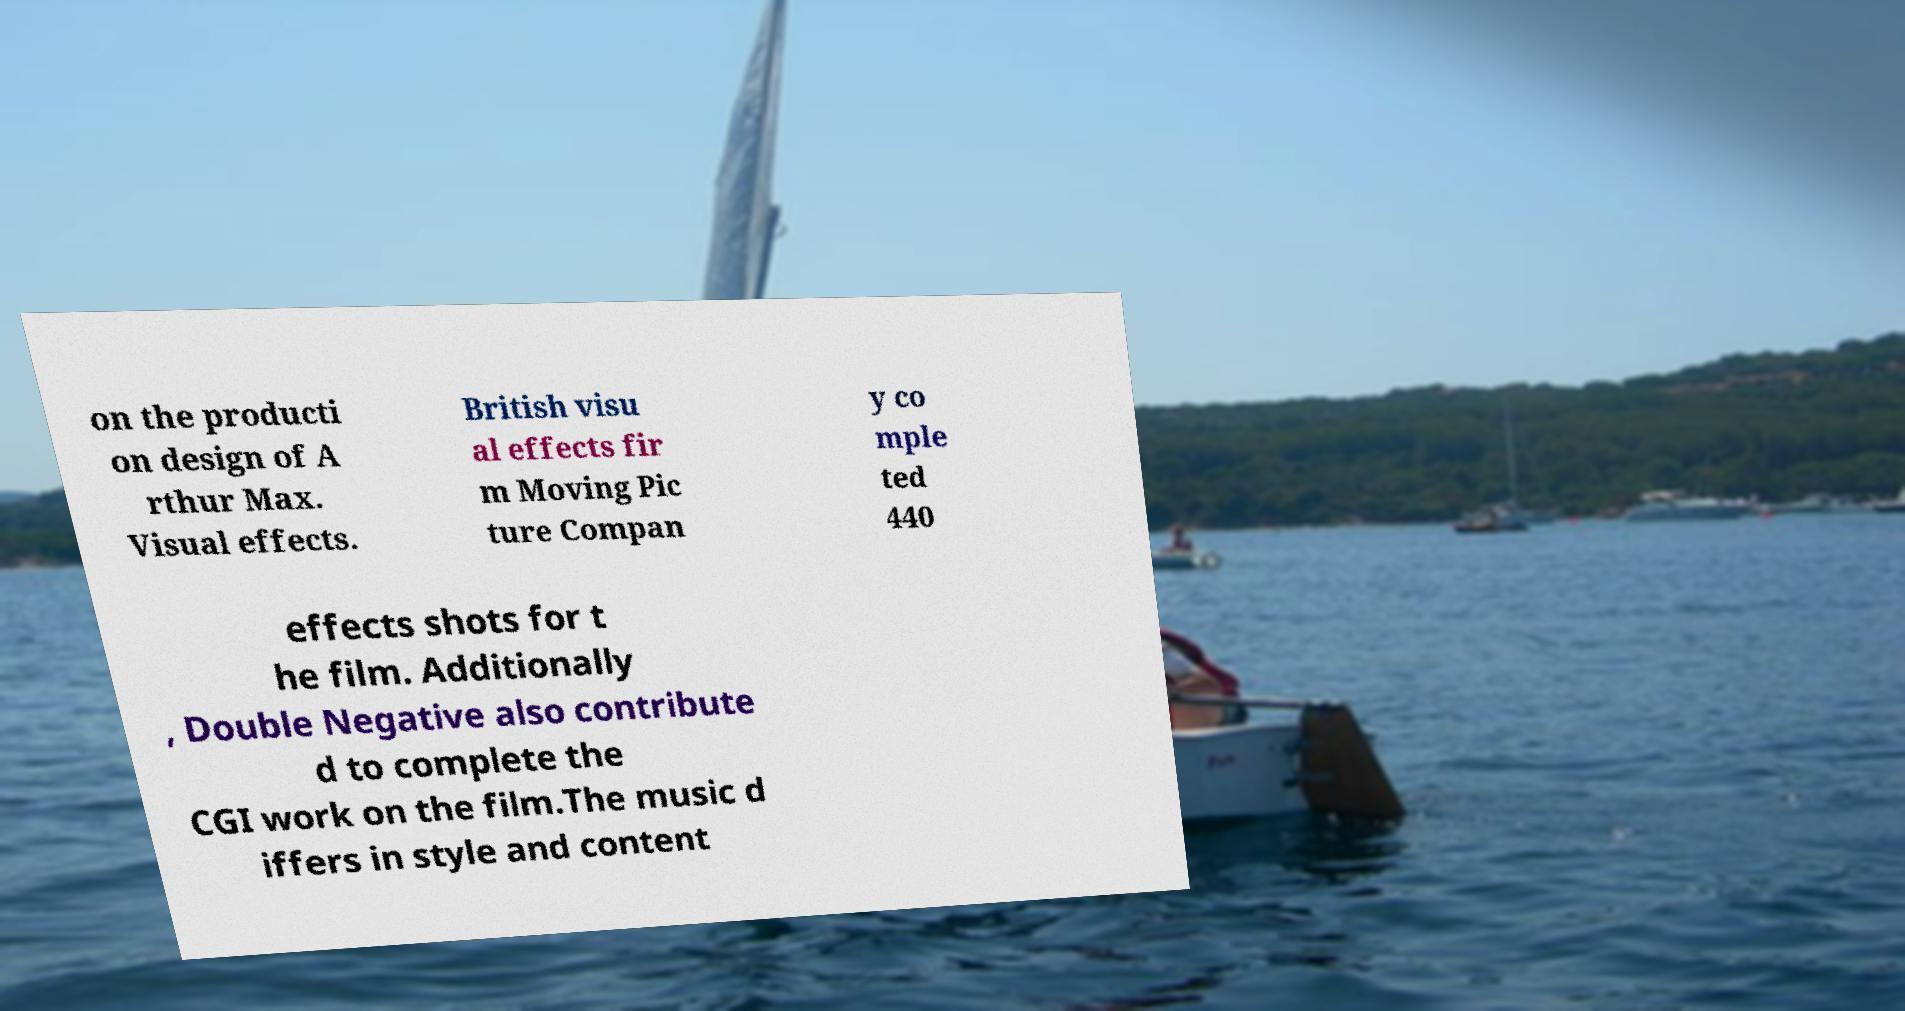I need the written content from this picture converted into text. Can you do that? on the producti on design of A rthur Max. Visual effects. British visu al effects fir m Moving Pic ture Compan y co mple ted 440 effects shots for t he film. Additionally , Double Negative also contribute d to complete the CGI work on the film.The music d iffers in style and content 